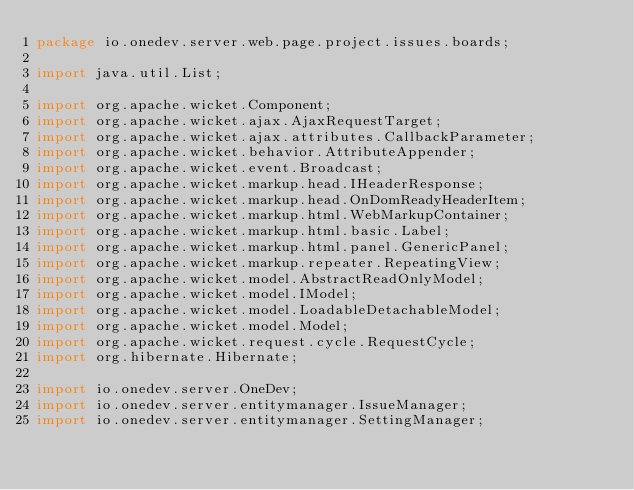<code> <loc_0><loc_0><loc_500><loc_500><_Java_>package io.onedev.server.web.page.project.issues.boards;

import java.util.List;

import org.apache.wicket.Component;
import org.apache.wicket.ajax.AjaxRequestTarget;
import org.apache.wicket.ajax.attributes.CallbackParameter;
import org.apache.wicket.behavior.AttributeAppender;
import org.apache.wicket.event.Broadcast;
import org.apache.wicket.markup.head.IHeaderResponse;
import org.apache.wicket.markup.head.OnDomReadyHeaderItem;
import org.apache.wicket.markup.html.WebMarkupContainer;
import org.apache.wicket.markup.html.basic.Label;
import org.apache.wicket.markup.html.panel.GenericPanel;
import org.apache.wicket.markup.repeater.RepeatingView;
import org.apache.wicket.model.AbstractReadOnlyModel;
import org.apache.wicket.model.IModel;
import org.apache.wicket.model.LoadableDetachableModel;
import org.apache.wicket.model.Model;
import org.apache.wicket.request.cycle.RequestCycle;
import org.hibernate.Hibernate;

import io.onedev.server.OneDev;
import io.onedev.server.entitymanager.IssueManager;
import io.onedev.server.entitymanager.SettingManager;</code> 